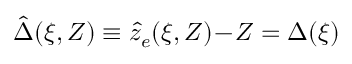<formula> <loc_0><loc_0><loc_500><loc_500>\hat { \Delta } ( \xi , Z ) \equiv \hat { z } _ { e } ( \xi , Z ) \, - \, Z = \Delta ( \xi )</formula> 